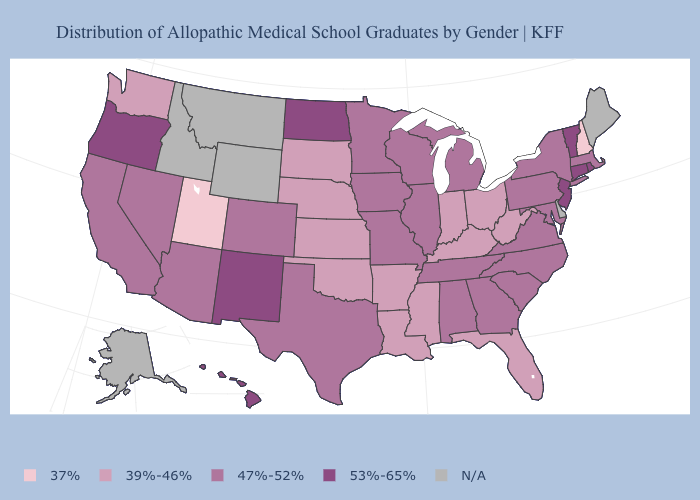Does North Dakota have the highest value in the MidWest?
Concise answer only. Yes. What is the value of Alaska?
Be succinct. N/A. What is the value of Colorado?
Answer briefly. 47%-52%. Name the states that have a value in the range 37%?
Answer briefly. New Hampshire, Utah. Name the states that have a value in the range 53%-65%?
Quick response, please. Connecticut, Hawaii, New Jersey, New Mexico, North Dakota, Oregon, Rhode Island, Vermont. Which states have the lowest value in the USA?
Short answer required. New Hampshire, Utah. Does the map have missing data?
Concise answer only. Yes. Name the states that have a value in the range 39%-46%?
Short answer required. Arkansas, Florida, Indiana, Kansas, Kentucky, Louisiana, Mississippi, Nebraska, Ohio, Oklahoma, South Dakota, Washington, West Virginia. What is the lowest value in the USA?
Answer briefly. 37%. Which states hav the highest value in the MidWest?
Be succinct. North Dakota. Does the first symbol in the legend represent the smallest category?
Short answer required. Yes. Name the states that have a value in the range 47%-52%?
Short answer required. Alabama, Arizona, California, Colorado, Georgia, Illinois, Iowa, Maryland, Massachusetts, Michigan, Minnesota, Missouri, Nevada, New York, North Carolina, Pennsylvania, South Carolina, Tennessee, Texas, Virginia, Wisconsin. Which states have the lowest value in the USA?
Give a very brief answer. New Hampshire, Utah. What is the lowest value in states that border Wyoming?
Give a very brief answer. 37%. 